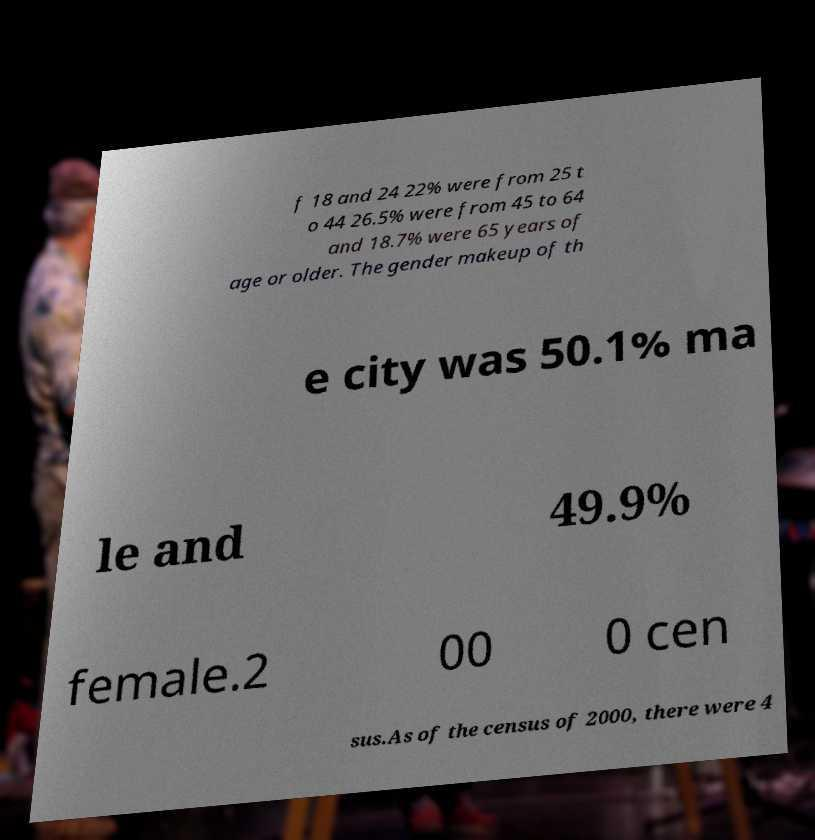Can you accurately transcribe the text from the provided image for me? f 18 and 24 22% were from 25 t o 44 26.5% were from 45 to 64 and 18.7% were 65 years of age or older. The gender makeup of th e city was 50.1% ma le and 49.9% female.2 00 0 cen sus.As of the census of 2000, there were 4 